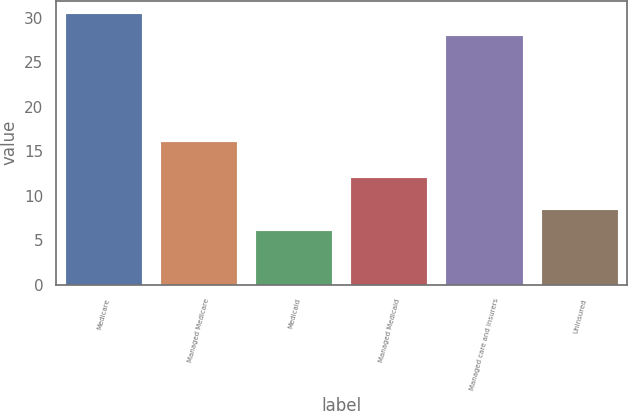Convert chart. <chart><loc_0><loc_0><loc_500><loc_500><bar_chart><fcel>Medicare<fcel>Managed Medicare<fcel>Medicaid<fcel>Managed Medicaid<fcel>Managed care and insurers<fcel>Uninsured<nl><fcel>30.4<fcel>16<fcel>6<fcel>12<fcel>28<fcel>8.4<nl></chart> 